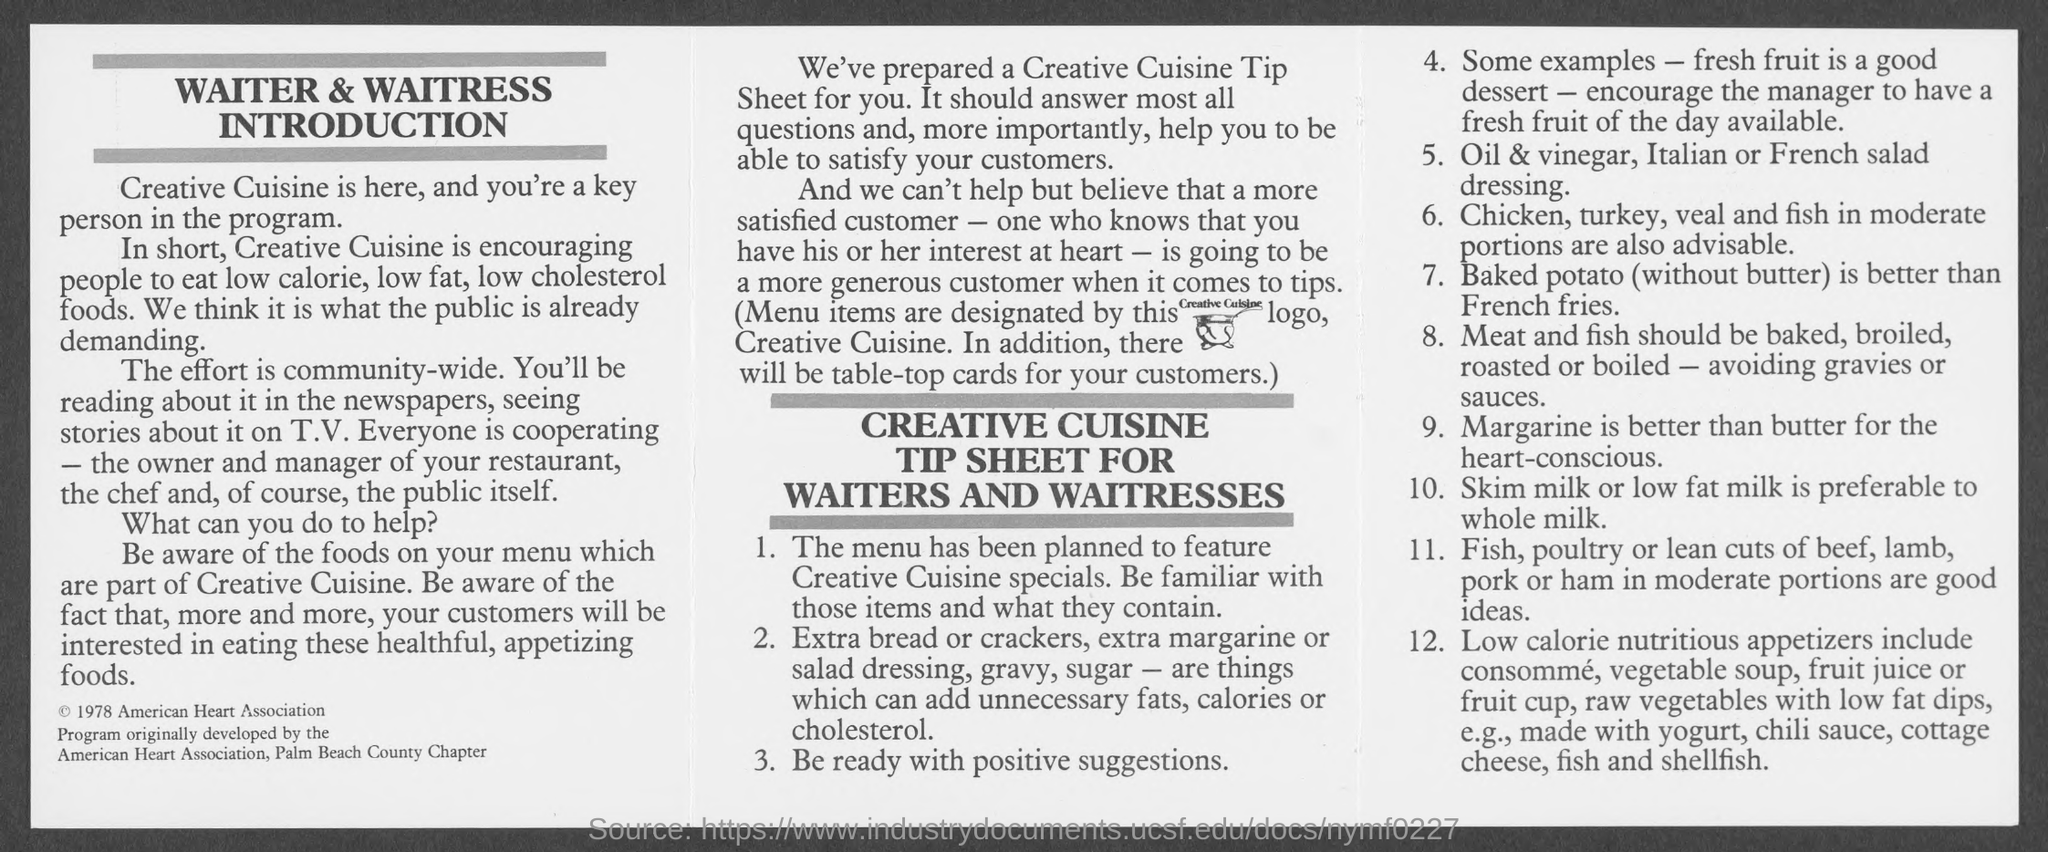Where does vegetable soup, consomme,fruit juices come under?
Offer a terse response. LOW CALORIE NUTRITIOUS APPETIZERS. Which type of milk is preferable ?
Provide a short and direct response. SKIM MILK OR LOW FAT MILK. 